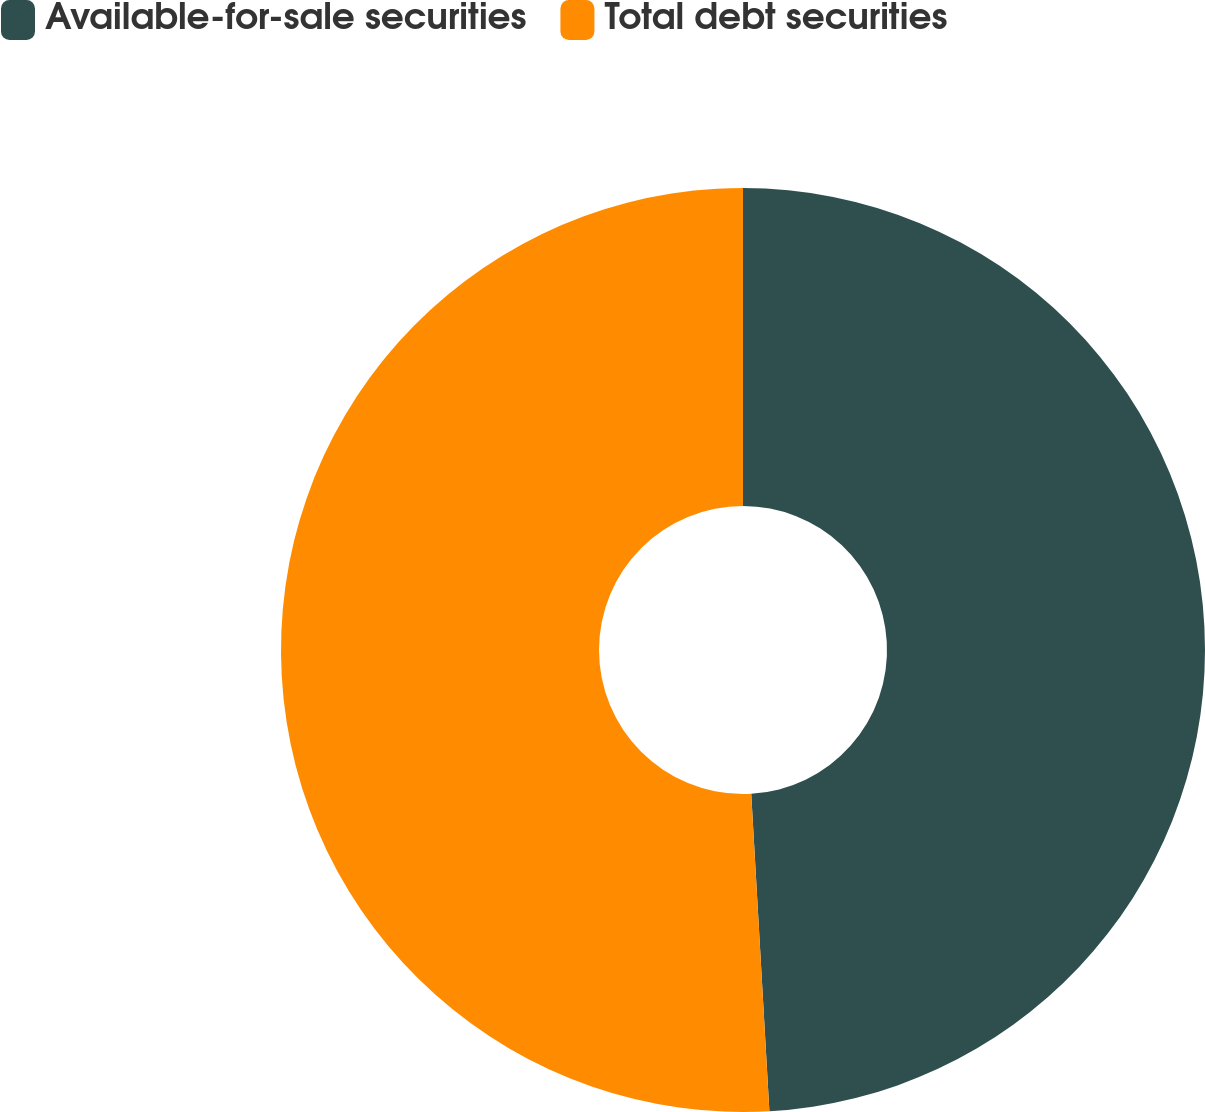<chart> <loc_0><loc_0><loc_500><loc_500><pie_chart><fcel>Available-for-sale securities<fcel>Total debt securities<nl><fcel>49.09%<fcel>50.91%<nl></chart> 